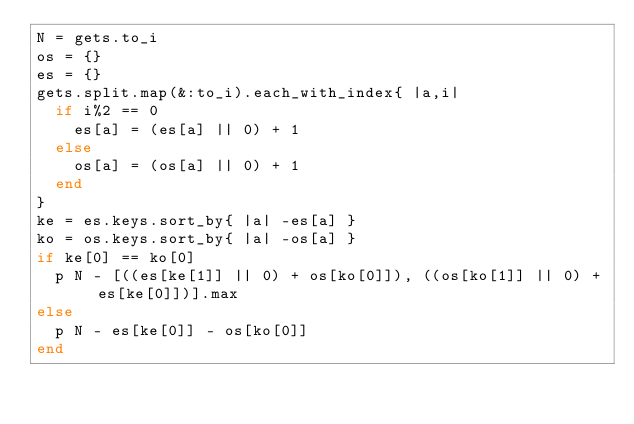<code> <loc_0><loc_0><loc_500><loc_500><_Ruby_>N = gets.to_i
os = {}
es = {}
gets.split.map(&:to_i).each_with_index{ |a,i|
  if i%2 == 0
    es[a] = (es[a] || 0) + 1
  else
    os[a] = (os[a] || 0) + 1
  end
}
ke = es.keys.sort_by{ |a| -es[a] }
ko = os.keys.sort_by{ |a| -os[a] }
if ke[0] == ko[0]
  p N - [((es[ke[1]] || 0) + os[ko[0]]), ((os[ko[1]] || 0) + es[ke[0]])].max
else
  p N - es[ke[0]] - os[ko[0]]
end
</code> 